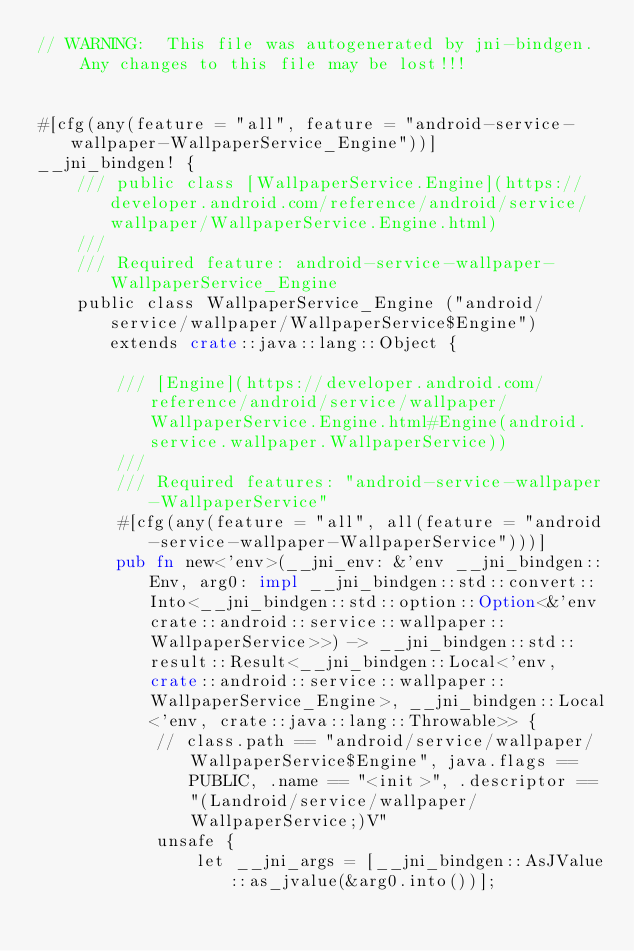<code> <loc_0><loc_0><loc_500><loc_500><_Rust_>// WARNING:  This file was autogenerated by jni-bindgen.  Any changes to this file may be lost!!!


#[cfg(any(feature = "all", feature = "android-service-wallpaper-WallpaperService_Engine"))]
__jni_bindgen! {
    /// public class [WallpaperService.Engine](https://developer.android.com/reference/android/service/wallpaper/WallpaperService.Engine.html)
    ///
    /// Required feature: android-service-wallpaper-WallpaperService_Engine
    public class WallpaperService_Engine ("android/service/wallpaper/WallpaperService$Engine") extends crate::java::lang::Object {

        /// [Engine](https://developer.android.com/reference/android/service/wallpaper/WallpaperService.Engine.html#Engine(android.service.wallpaper.WallpaperService))
        ///
        /// Required features: "android-service-wallpaper-WallpaperService"
        #[cfg(any(feature = "all", all(feature = "android-service-wallpaper-WallpaperService")))]
        pub fn new<'env>(__jni_env: &'env __jni_bindgen::Env, arg0: impl __jni_bindgen::std::convert::Into<__jni_bindgen::std::option::Option<&'env crate::android::service::wallpaper::WallpaperService>>) -> __jni_bindgen::std::result::Result<__jni_bindgen::Local<'env, crate::android::service::wallpaper::WallpaperService_Engine>, __jni_bindgen::Local<'env, crate::java::lang::Throwable>> {
            // class.path == "android/service/wallpaper/WallpaperService$Engine", java.flags == PUBLIC, .name == "<init>", .descriptor == "(Landroid/service/wallpaper/WallpaperService;)V"
            unsafe {
                let __jni_args = [__jni_bindgen::AsJValue::as_jvalue(&arg0.into())];</code> 